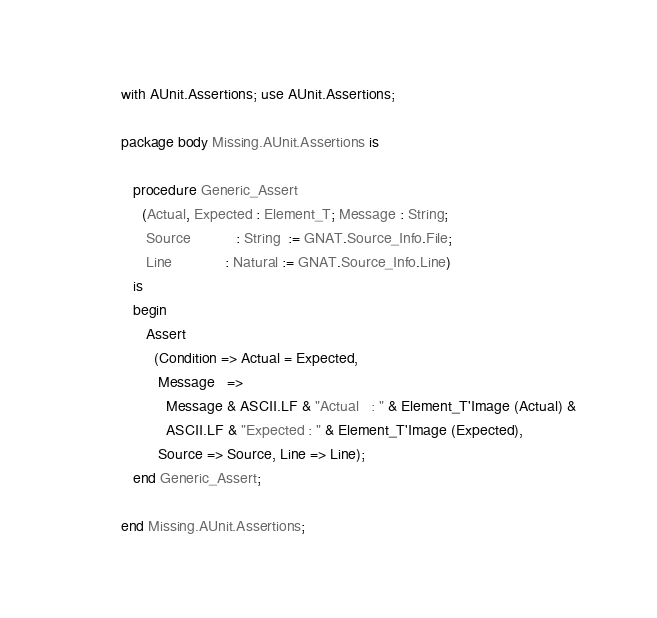<code> <loc_0><loc_0><loc_500><loc_500><_Ada_>with AUnit.Assertions; use AUnit.Assertions;

package body Missing.AUnit.Assertions is

   procedure Generic_Assert
     (Actual, Expected : Element_T; Message : String;
      Source           : String  := GNAT.Source_Info.File;
      Line             : Natural := GNAT.Source_Info.Line)
   is
   begin
      Assert
        (Condition => Actual = Expected,
         Message   =>
           Message & ASCII.LF & "Actual   : " & Element_T'Image (Actual) &
           ASCII.LF & "Expected : " & Element_T'Image (Expected),
         Source => Source, Line => Line);
   end Generic_Assert;

end Missing.AUnit.Assertions;
</code> 